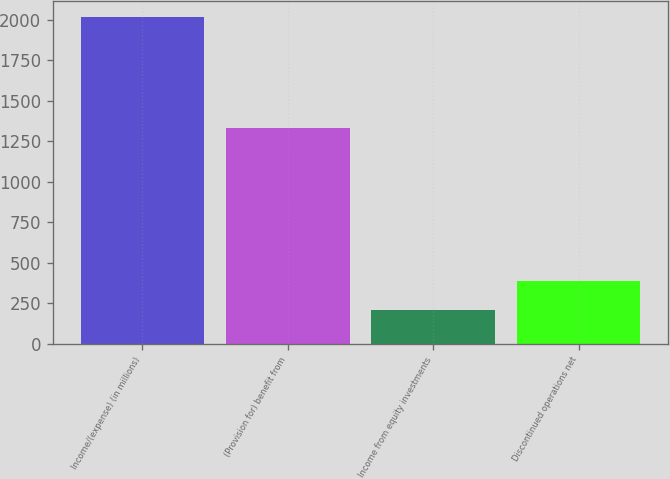<chart> <loc_0><loc_0><loc_500><loc_500><bar_chart><fcel>Income/(expense) (in millions)<fcel>(Provision for) benefit from<fcel>Income from equity investments<fcel>Discontinued operations net<nl><fcel>2015<fcel>1330<fcel>208<fcel>388.7<nl></chart> 